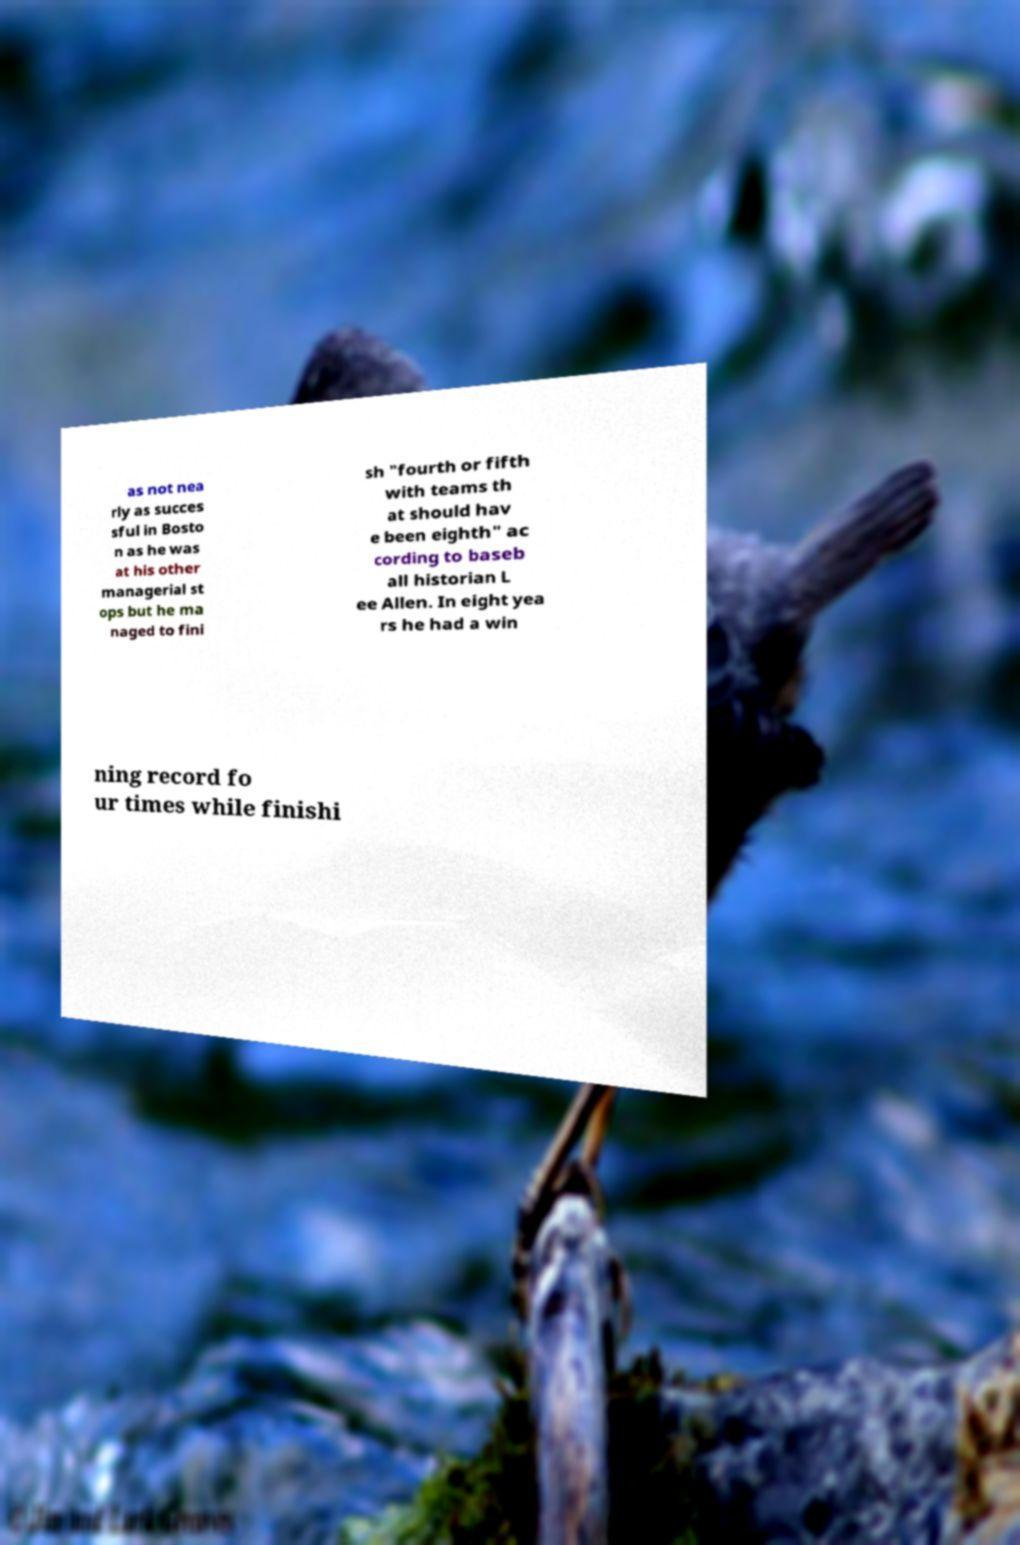Can you read and provide the text displayed in the image?This photo seems to have some interesting text. Can you extract and type it out for me? as not nea rly as succes sful in Bosto n as he was at his other managerial st ops but he ma naged to fini sh "fourth or fifth with teams th at should hav e been eighth" ac cording to baseb all historian L ee Allen. In eight yea rs he had a win ning record fo ur times while finishi 